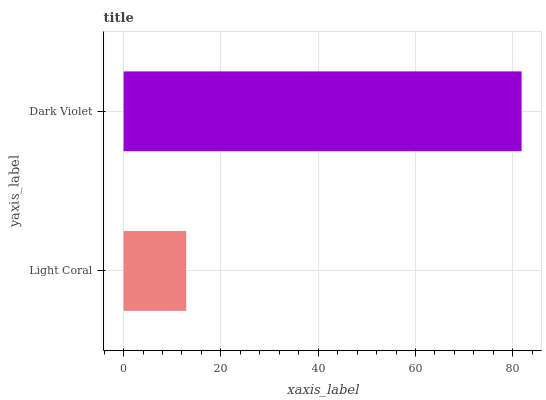Is Light Coral the minimum?
Answer yes or no. Yes. Is Dark Violet the maximum?
Answer yes or no. Yes. Is Dark Violet the minimum?
Answer yes or no. No. Is Dark Violet greater than Light Coral?
Answer yes or no. Yes. Is Light Coral less than Dark Violet?
Answer yes or no. Yes. Is Light Coral greater than Dark Violet?
Answer yes or no. No. Is Dark Violet less than Light Coral?
Answer yes or no. No. Is Dark Violet the high median?
Answer yes or no. Yes. Is Light Coral the low median?
Answer yes or no. Yes. Is Light Coral the high median?
Answer yes or no. No. Is Dark Violet the low median?
Answer yes or no. No. 